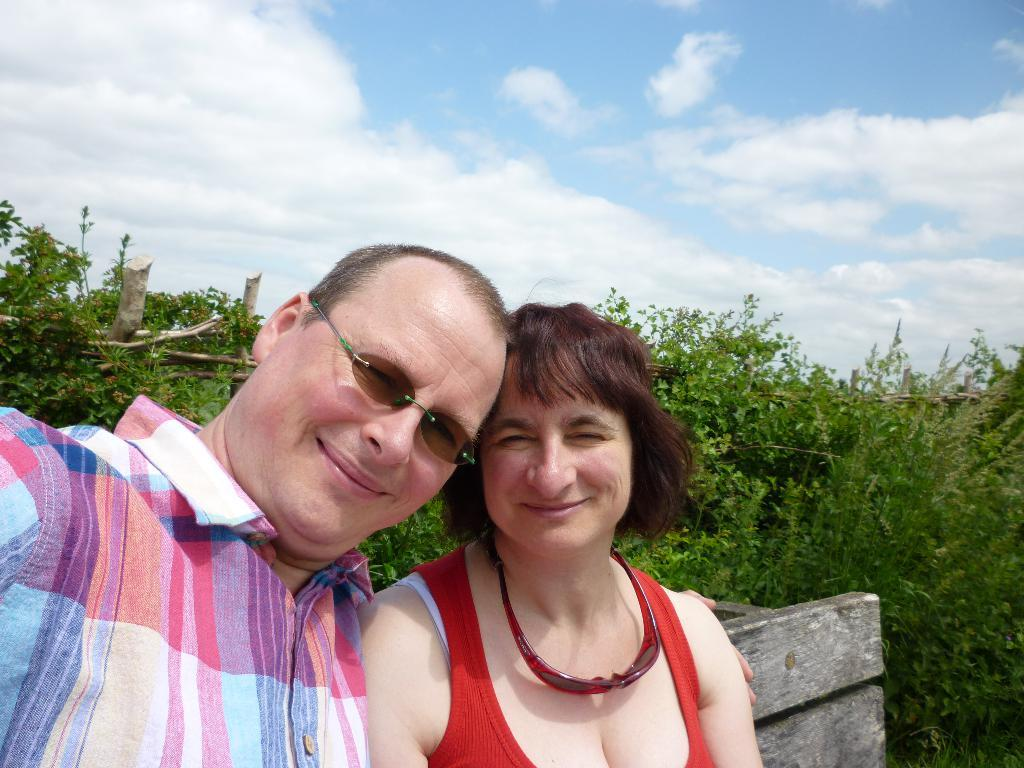How many people are present in the image? There are two people in the image. What can be observed about the clothing of the people in the image? The people are wearing different color dresses. What type of object can be seen in the image? There is a wooden object in the image. What can be seen in the background of the image? There are plants, clouds, and the sky visible in the background of the image. What color is the eye of the person on the left in the image? There is no mention of an eye or any facial features in the provided facts, so it is not possible to answer this question. 